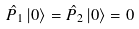Convert formula to latex. <formula><loc_0><loc_0><loc_500><loc_500>\hat { P } _ { 1 } \left | 0 \right \rangle = \hat { P } _ { 2 } \left | 0 \right \rangle = 0</formula> 